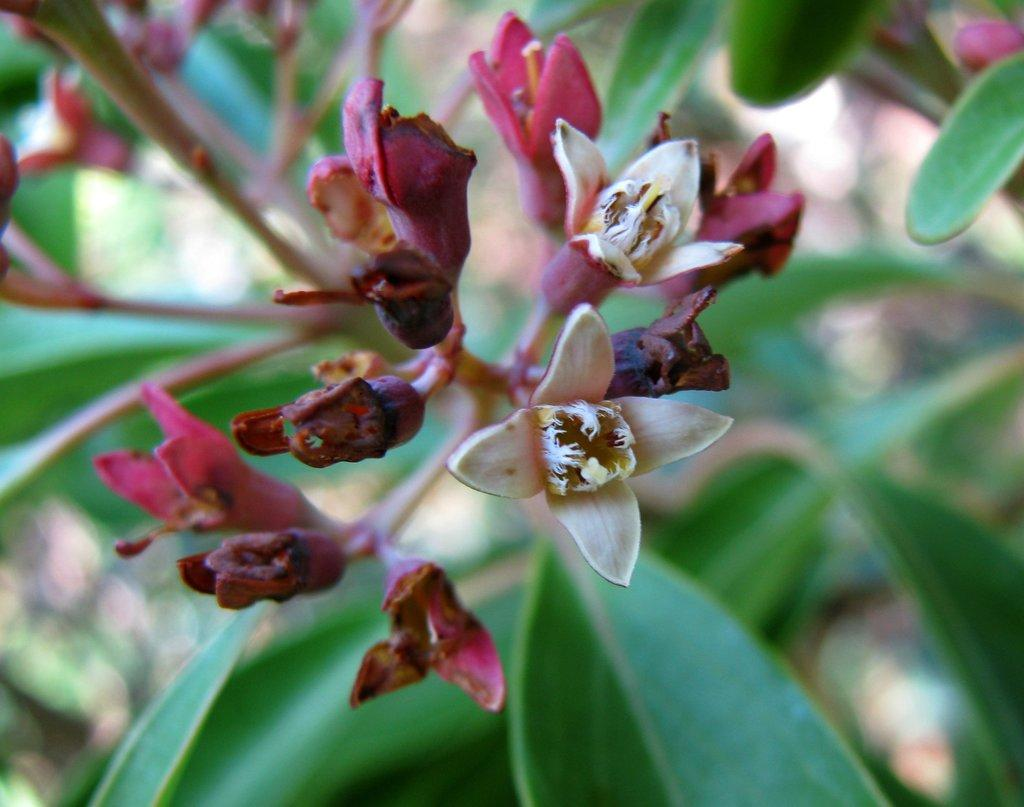What type of living organism is in the image? There is a plant in the image. What color are the leaves of the plant? The plant has green leaves. Are there any additional features on the plant? Yes, there are flowers on the plant. What is the parent's reaction to the plant in the image? There is no parent or reaction mentioned in the image; it simply shows a plant with green leaves and flowers. 